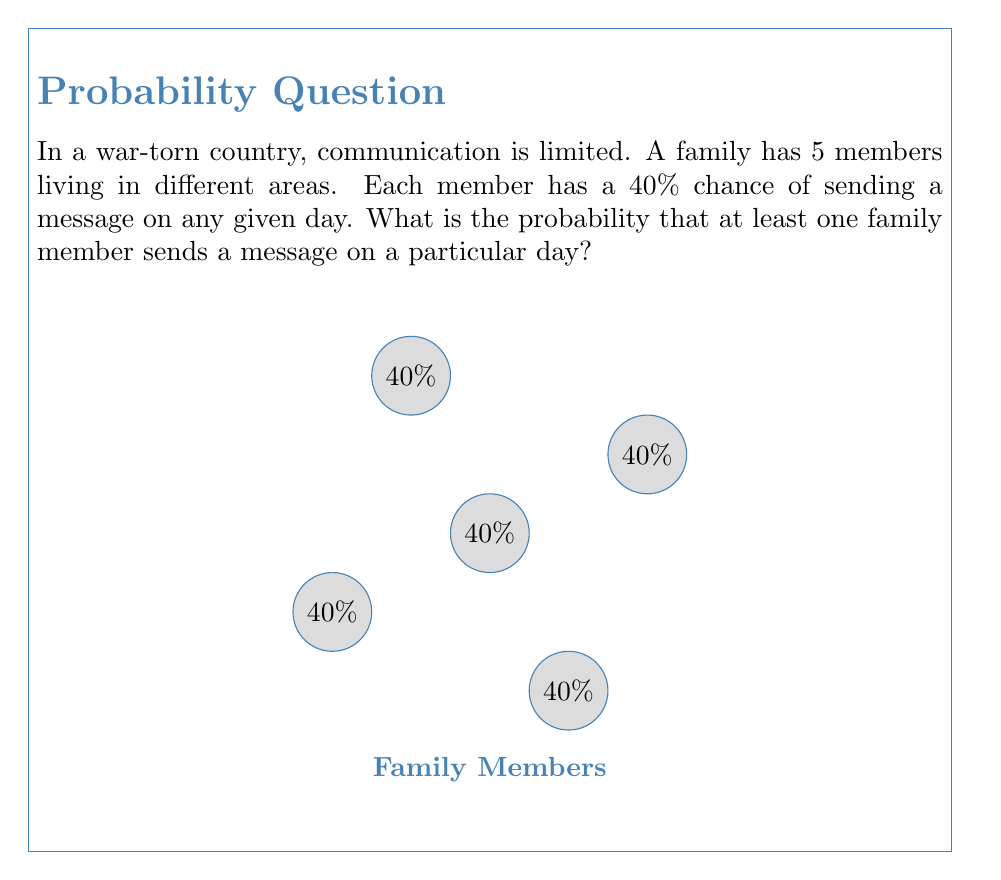What is the answer to this math problem? Let's approach this step-by-step:

1) First, let's calculate the probability that a single family member does not send a message:
   $P(\text{no message}) = 1 - 0.40 = 0.60$ or 60%

2) For at least one member to send a message, we can calculate the probability that not all members fail to send a message:

3) The probability that all 5 members fail to send a message is:
   $P(\text{all fail}) = 0.60^5 = 0.07776$ or about 7.776%

4) Therefore, the probability that at least one member sends a message is:
   $P(\text{at least one}) = 1 - P(\text{all fail})$
   $= 1 - 0.07776$
   $= 0.92224$

5) Converting to a percentage:
   $0.92224 * 100\% = 92.224\%$

Thus, there is a 92.224% chance that at least one family member sends a message on a given day.
Answer: $92.224\%$ 